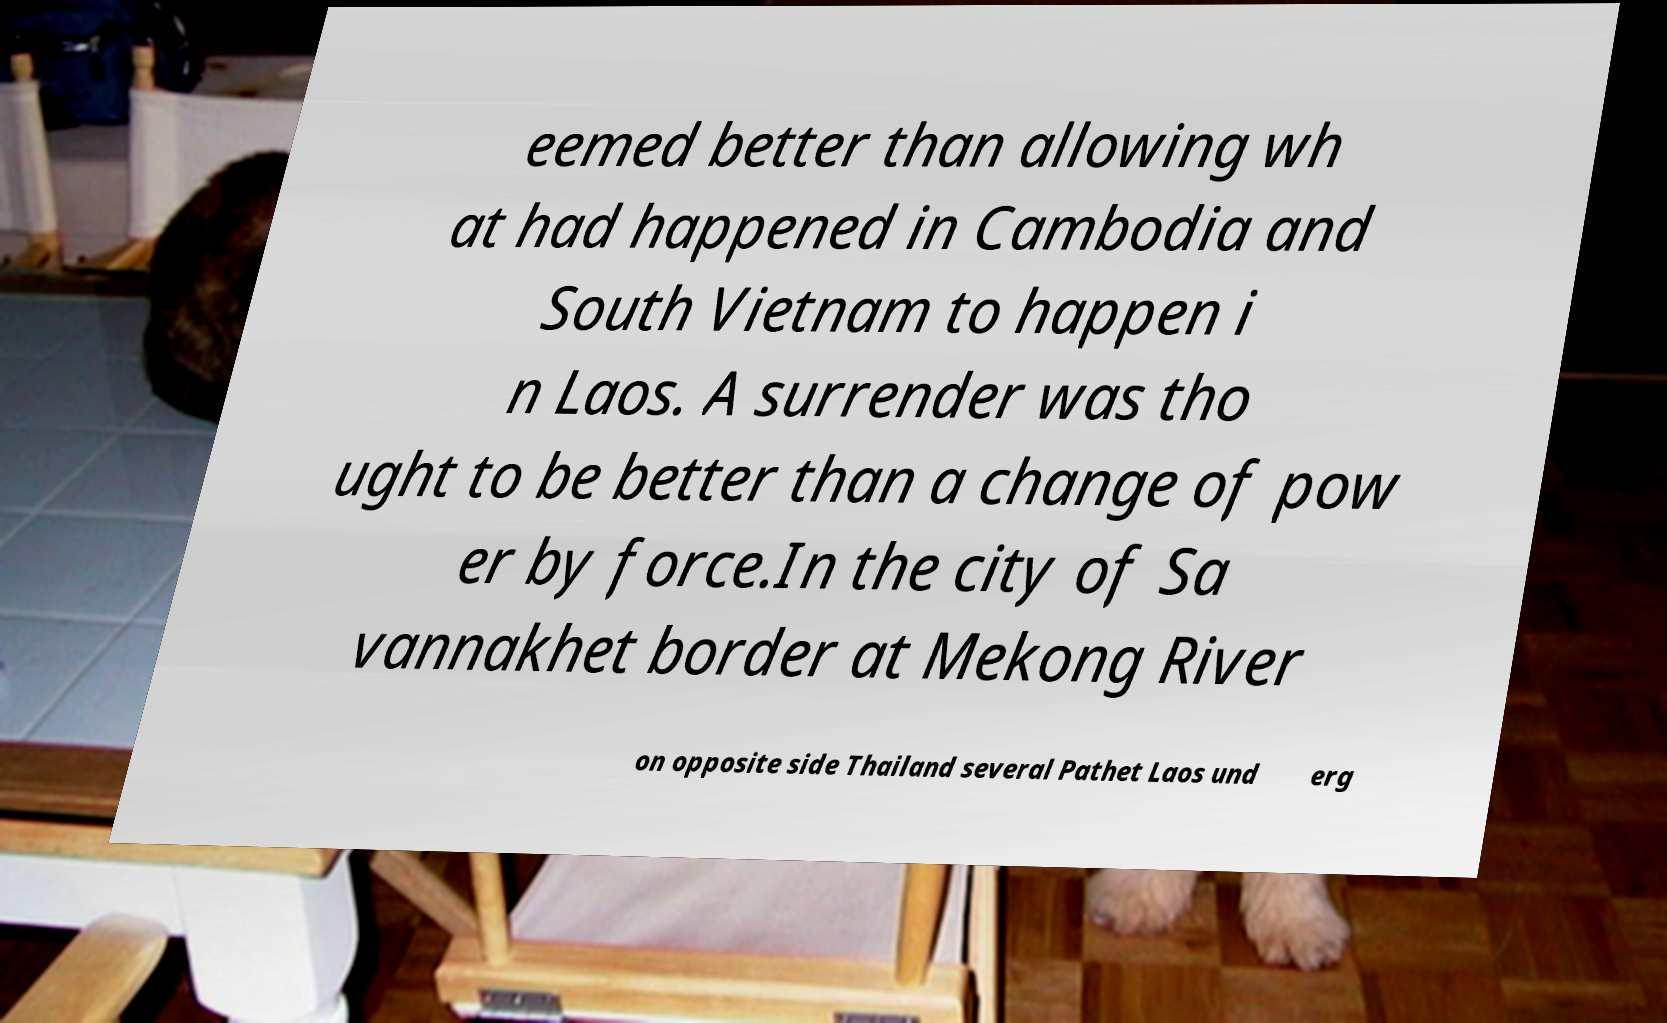Please read and relay the text visible in this image. What does it say? eemed better than allowing wh at had happened in Cambodia and South Vietnam to happen i n Laos. A surrender was tho ught to be better than a change of pow er by force.In the city of Sa vannakhet border at Mekong River on opposite side Thailand several Pathet Laos und erg 